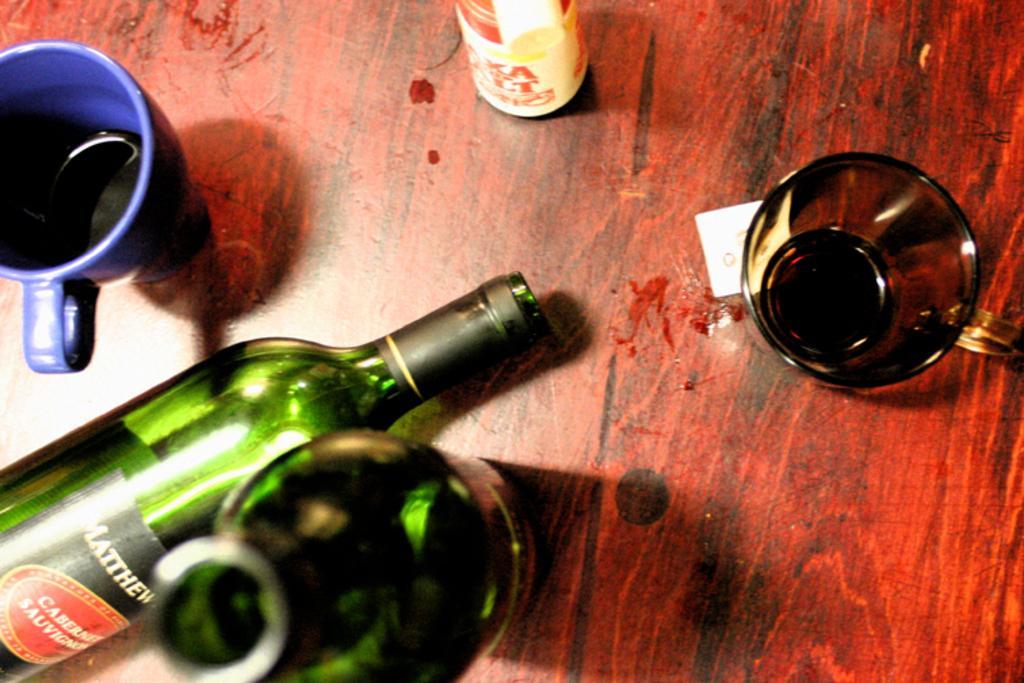Can you describe this image briefly? on a table there is a blue glass, green glass bottles and another glass. 